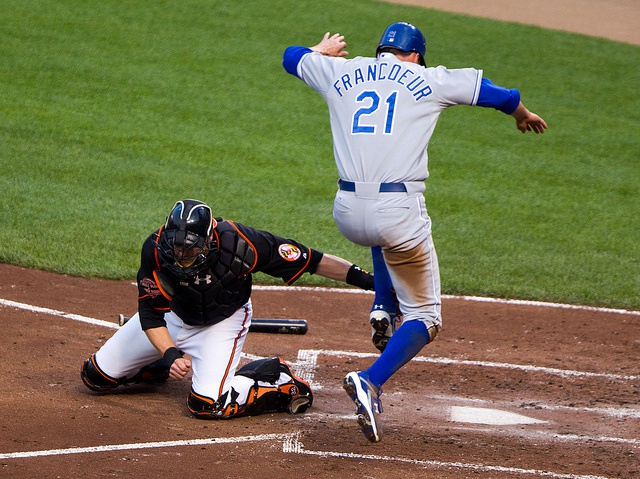Describe the objects in this image and their specific colors. I can see people in green, lavender, darkgray, and navy tones, people in green, black, lavender, maroon, and gray tones, and baseball bat in green, black, navy, gray, and darkgray tones in this image. 